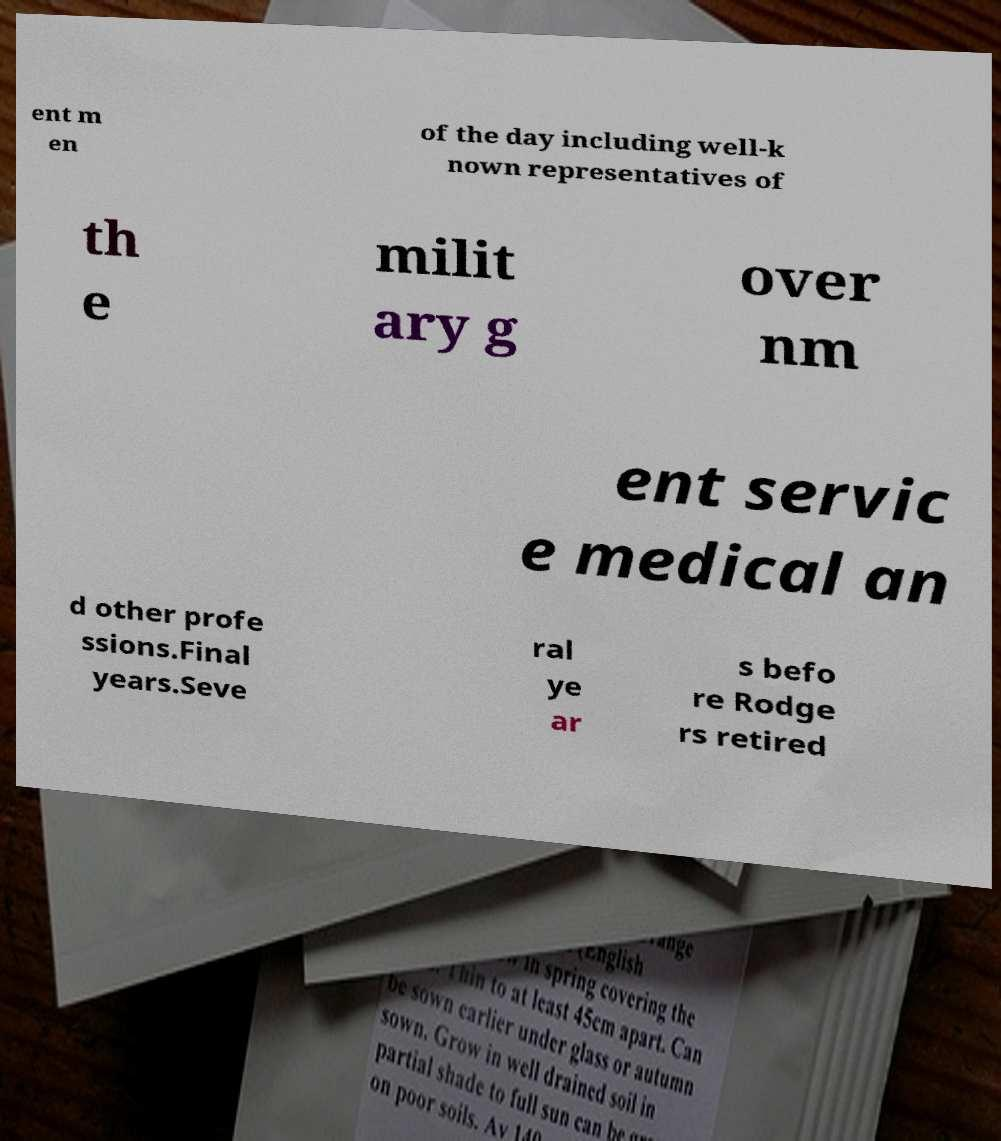Could you assist in decoding the text presented in this image and type it out clearly? ent m en of the day including well-k nown representatives of th e milit ary g over nm ent servic e medical an d other profe ssions.Final years.Seve ral ye ar s befo re Rodge rs retired 